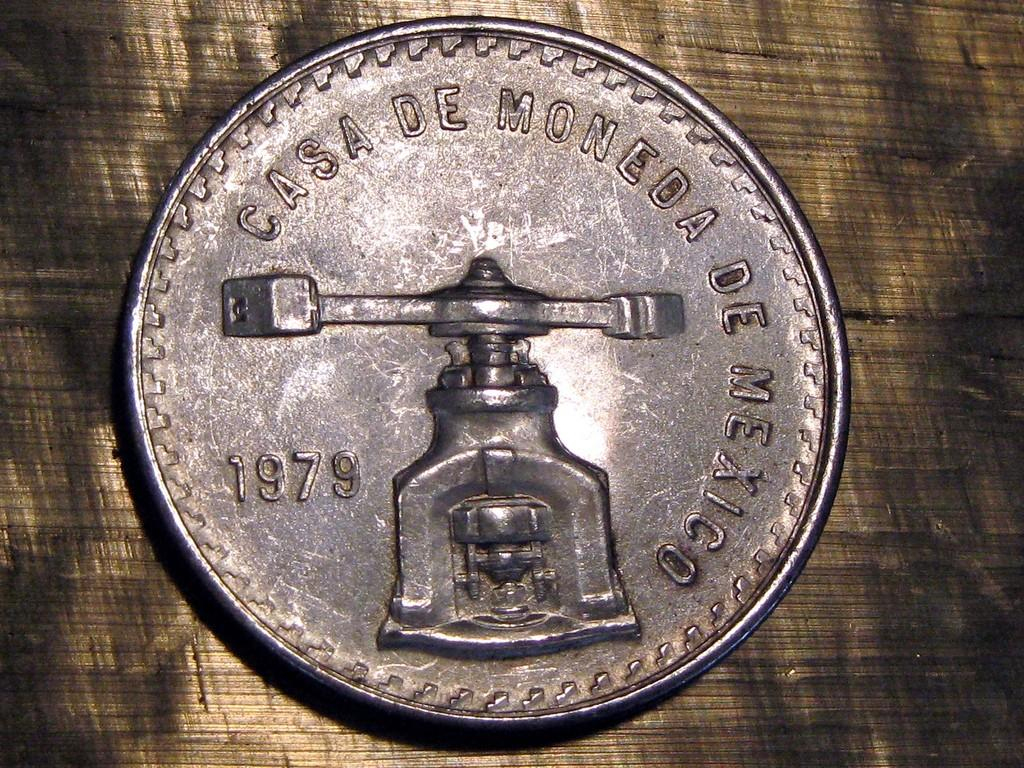<image>
Present a compact description of the photo's key features. A coin from 1979 says "Casa de Moneda de Mexico" on it. 